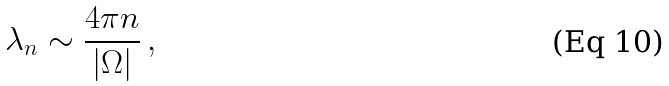<formula> <loc_0><loc_0><loc_500><loc_500>\lambda _ { n } \sim \frac { 4 \pi n } { | \Omega | } \, ,</formula> 